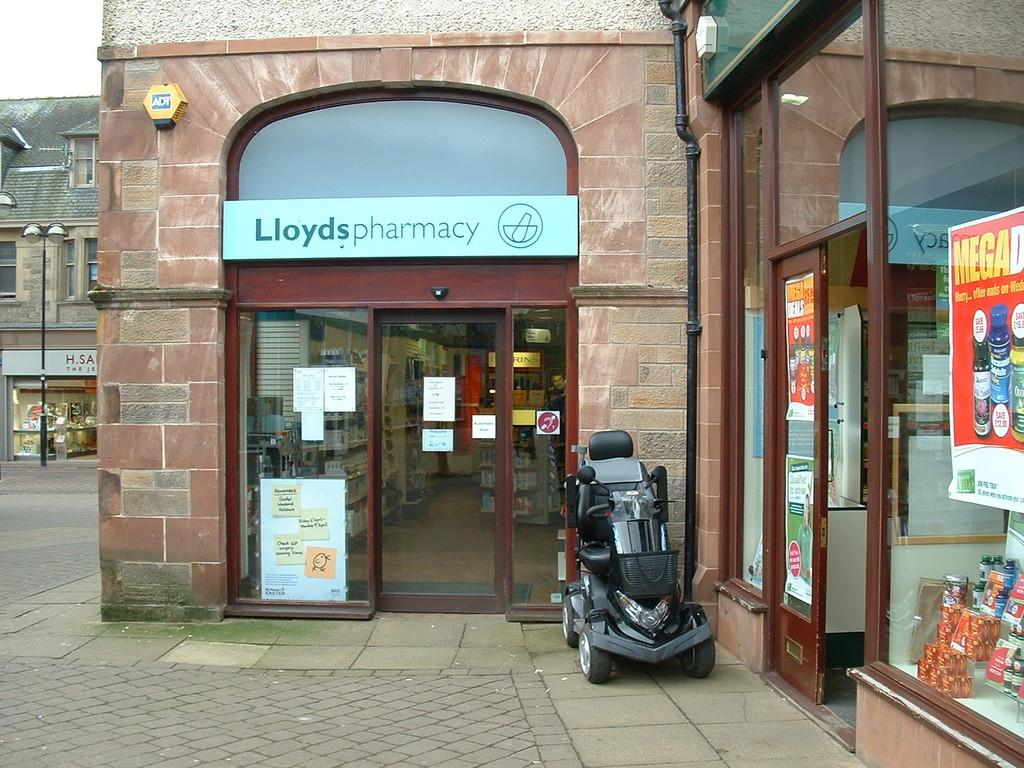What type of establishment is shown in the image? There is a pharmacy store in the image. Is there anything in front of the pharmacy store? Yes, there is a vehicle in front of the pharmacy store. What can be seen in the left corner of the image? There is a building in the left corner of the image. What type of quartz is displayed on the shelves inside the pharmacy store? There is no quartz present in the image, as it is a pharmacy store and not a crystal shop. Can you see any popcorn being sold at the pharmacy store? There is no popcorn visible in the image, as it is a pharmacy store and not a movie theater or snack shop. 